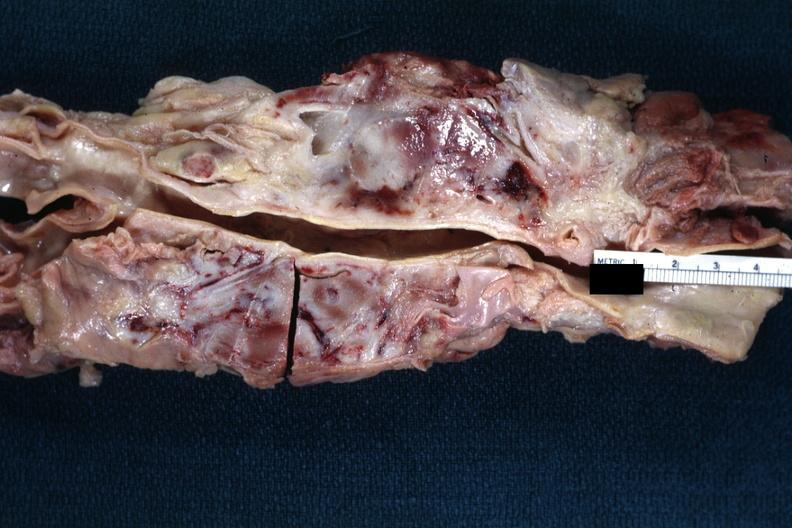does this image show matted and fused periaortic nodes with hemorrhagic necrosis good example?
Answer the question using a single word or phrase. Yes 